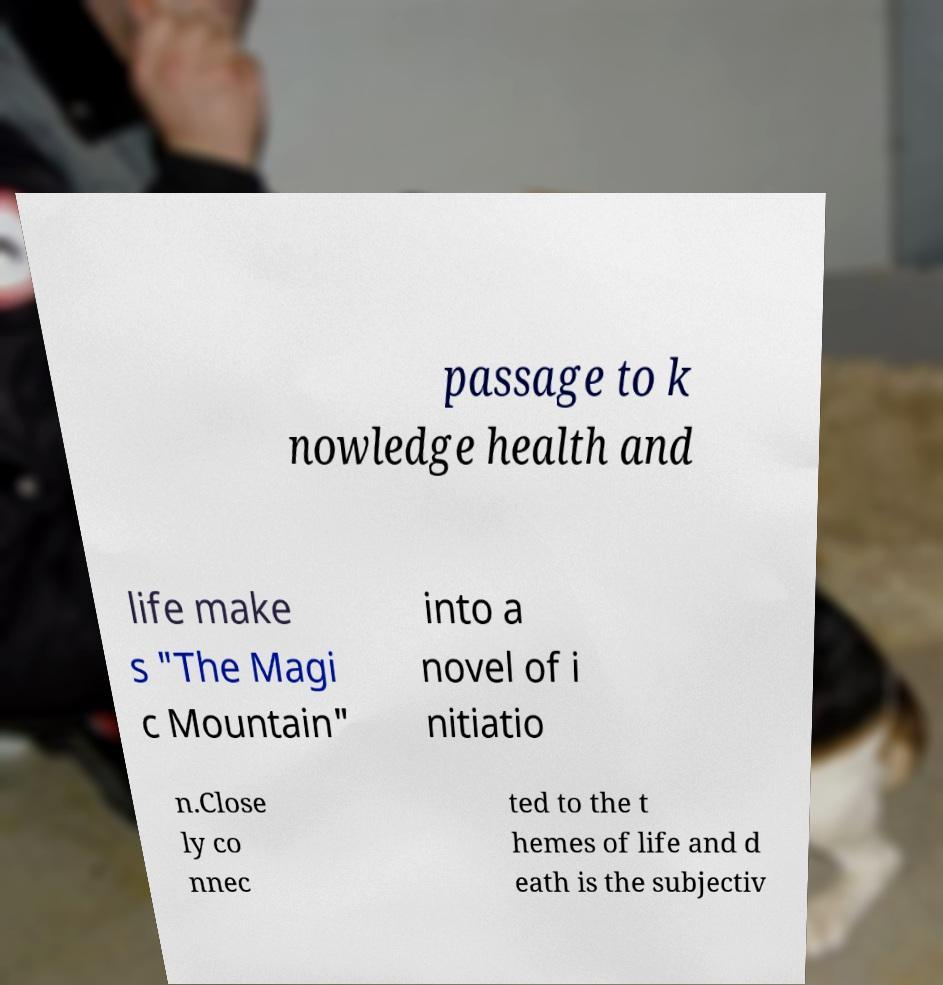Please read and relay the text visible in this image. What does it say? passage to k nowledge health and life make s "The Magi c Mountain" into a novel of i nitiatio n.Close ly co nnec ted to the t hemes of life and d eath is the subjectiv 